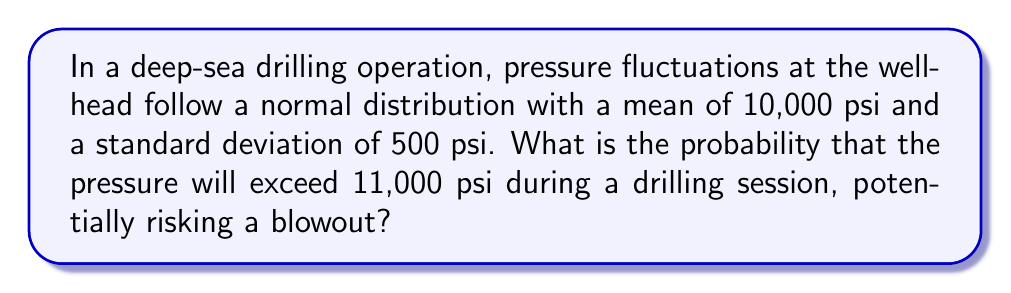Solve this math problem. To solve this problem, we need to use the properties of the normal distribution and the concept of z-scores.

Step 1: Identify the given information
- Mean pressure (μ) = 10,000 psi
- Standard deviation (σ) = 500 psi
- We want to find P(X > 11,000)

Step 2: Calculate the z-score for 11,000 psi
The z-score formula is:
$$ z = \frac{x - \mu}{\sigma} $$

Plugging in the values:
$$ z = \frac{11,000 - 10,000}{500} = \frac{1000}{500} = 2 $$

Step 3: Use the standard normal distribution table or calculator
We need to find P(Z > 2), which is the area to the right of z = 2 on the standard normal distribution.

Using a standard normal table or calculator, we find:
$$ P(Z > 2) = 1 - P(Z \leq 2) = 1 - 0.9772 = 0.0228 $$

Step 4: Interpret the result
The probability that the pressure will exceed 11,000 psi is approximately 0.0228 or 2.28%.

This relatively low probability suggests that while pressure spikes above 11,000 psi are possible, they are not common occurrences. However, given the potential consequences of a blowout, even this small probability warrants careful monitoring and robust safety measures in deep-sea drilling operations.
Answer: 0.0228 or 2.28% 